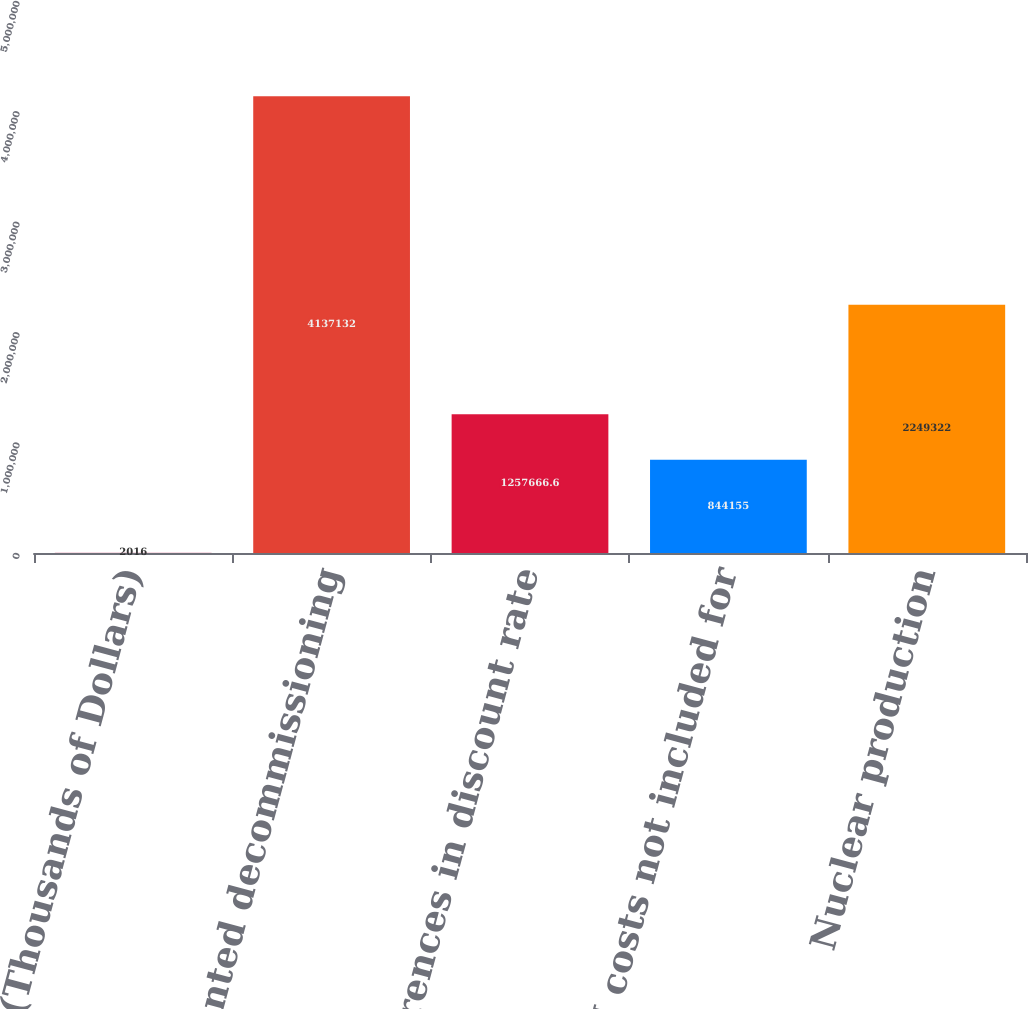Convert chart to OTSL. <chart><loc_0><loc_0><loc_500><loc_500><bar_chart><fcel>(Thousands of Dollars)<fcel>Discounted decommissioning<fcel>Differences in discount rate<fcel>O&M costs not included for<fcel>Nuclear production<nl><fcel>2016<fcel>4.13713e+06<fcel>1.25767e+06<fcel>844155<fcel>2.24932e+06<nl></chart> 